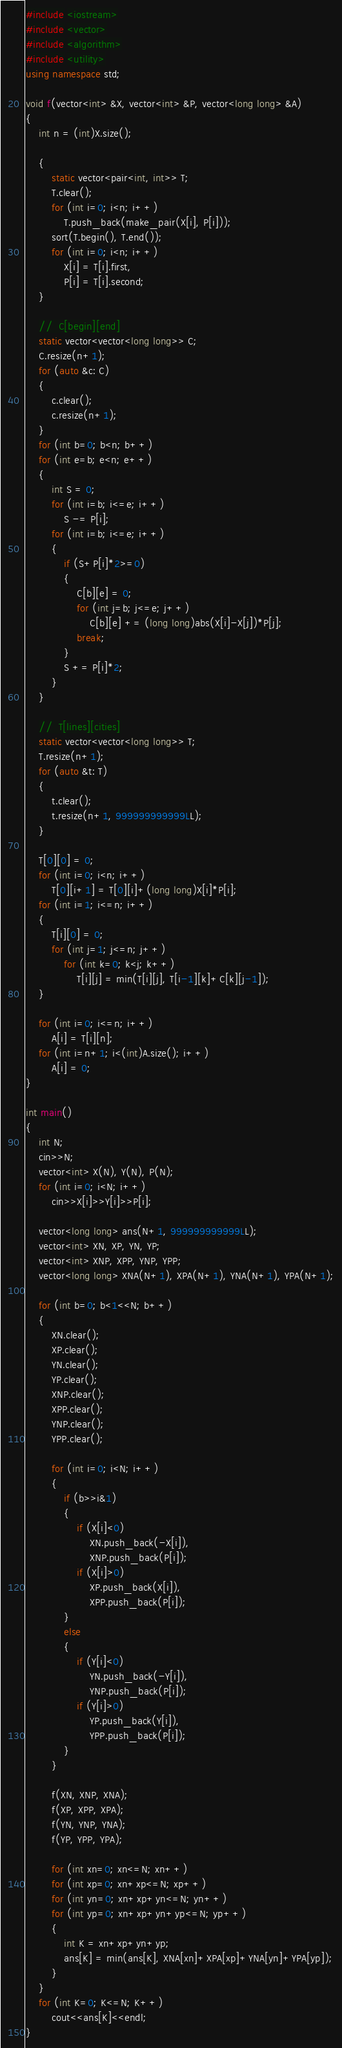Convert code to text. <code><loc_0><loc_0><loc_500><loc_500><_C++_>#include <iostream>
#include <vector>
#include <algorithm>
#include <utility>
using namespace std;

void f(vector<int> &X, vector<int> &P, vector<long long> &A)
{
    int n = (int)X.size();

    {
        static vector<pair<int, int>> T;
        T.clear();
        for (int i=0; i<n; i++)
            T.push_back(make_pair(X[i], P[i]));
        sort(T.begin(), T.end());
        for (int i=0; i<n; i++)
            X[i] = T[i].first,
            P[i] = T[i].second;
    }

    //  C[begin][end]
    static vector<vector<long long>> C;
    C.resize(n+1);
    for (auto &c: C)
    {
        c.clear();
        c.resize(n+1);
    }
    for (int b=0; b<n; b++)
    for (int e=b; e<n; e++)
    {
        int S = 0;
        for (int i=b; i<=e; i++)
            S -= P[i];
        for (int i=b; i<=e; i++)
        {
            if (S+P[i]*2>=0)
            {
                C[b][e] = 0;
                for (int j=b; j<=e; j++)
                    C[b][e] += (long long)abs(X[i]-X[j])*P[j];
                break;
            }
            S += P[i]*2;
        }
    }

    //  T[lines][cities]
    static vector<vector<long long>> T;
    T.resize(n+1);
    for (auto &t: T)
    {
        t.clear();
        t.resize(n+1, 999999999999LL);
    }

    T[0][0] = 0;
    for (int i=0; i<n; i++)
        T[0][i+1] = T[0][i]+(long long)X[i]*P[i];
    for (int i=1; i<=n; i++)
    {
        T[i][0] = 0;
        for (int j=1; j<=n; j++)
            for (int k=0; k<j; k++)
                T[i][j] = min(T[i][j], T[i-1][k]+C[k][j-1]);
    }

    for (int i=0; i<=n; i++)
        A[i] = T[i][n];
    for (int i=n+1; i<(int)A.size(); i++)
        A[i] = 0;
}

int main()
{
    int N;
    cin>>N;
    vector<int> X(N), Y(N), P(N);
    for (int i=0; i<N; i++)
        cin>>X[i]>>Y[i]>>P[i];

    vector<long long> ans(N+1, 999999999999LL);
    vector<int> XN, XP, YN, YP;
    vector<int> XNP, XPP, YNP, YPP;
    vector<long long> XNA(N+1), XPA(N+1), YNA(N+1), YPA(N+1);

    for (int b=0; b<1<<N; b++)
    {
        XN.clear();
        XP.clear();
        YN.clear();
        YP.clear();
        XNP.clear();
        XPP.clear();
        YNP.clear();
        YPP.clear();

        for (int i=0; i<N; i++)
        {
            if (b>>i&1)
            {
                if (X[i]<0)
                    XN.push_back(-X[i]),
                    XNP.push_back(P[i]);
                if (X[i]>0)
                    XP.push_back(X[i]),
                    XPP.push_back(P[i]);
            }
            else
            {
                if (Y[i]<0)
                    YN.push_back(-Y[i]),
                    YNP.push_back(P[i]);
                if (Y[i]>0)
                    YP.push_back(Y[i]),
                    YPP.push_back(P[i]);
            }
        }

        f(XN, XNP, XNA);
        f(XP, XPP, XPA);
        f(YN, YNP, YNA);
        f(YP, YPP, YPA);

        for (int xn=0; xn<=N; xn++)
        for (int xp=0; xn+xp<=N; xp++)
        for (int yn=0; xn+xp+yn<=N; yn++)
        for (int yp=0; xn+xp+yn+yp<=N; yp++)
        {
            int K = xn+xp+yn+yp;
            ans[K] = min(ans[K], XNA[xn]+XPA[xp]+YNA[yn]+YPA[yp]);
        }
    }
    for (int K=0; K<=N; K++)
        cout<<ans[K]<<endl;
}
</code> 